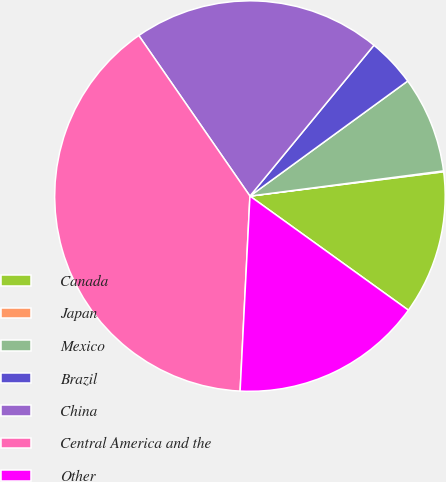Convert chart to OTSL. <chart><loc_0><loc_0><loc_500><loc_500><pie_chart><fcel>Canada<fcel>Japan<fcel>Mexico<fcel>Brazil<fcel>China<fcel>Central America and the<fcel>Other<nl><fcel>11.92%<fcel>0.07%<fcel>7.97%<fcel>4.02%<fcel>20.59%<fcel>39.56%<fcel>15.87%<nl></chart> 